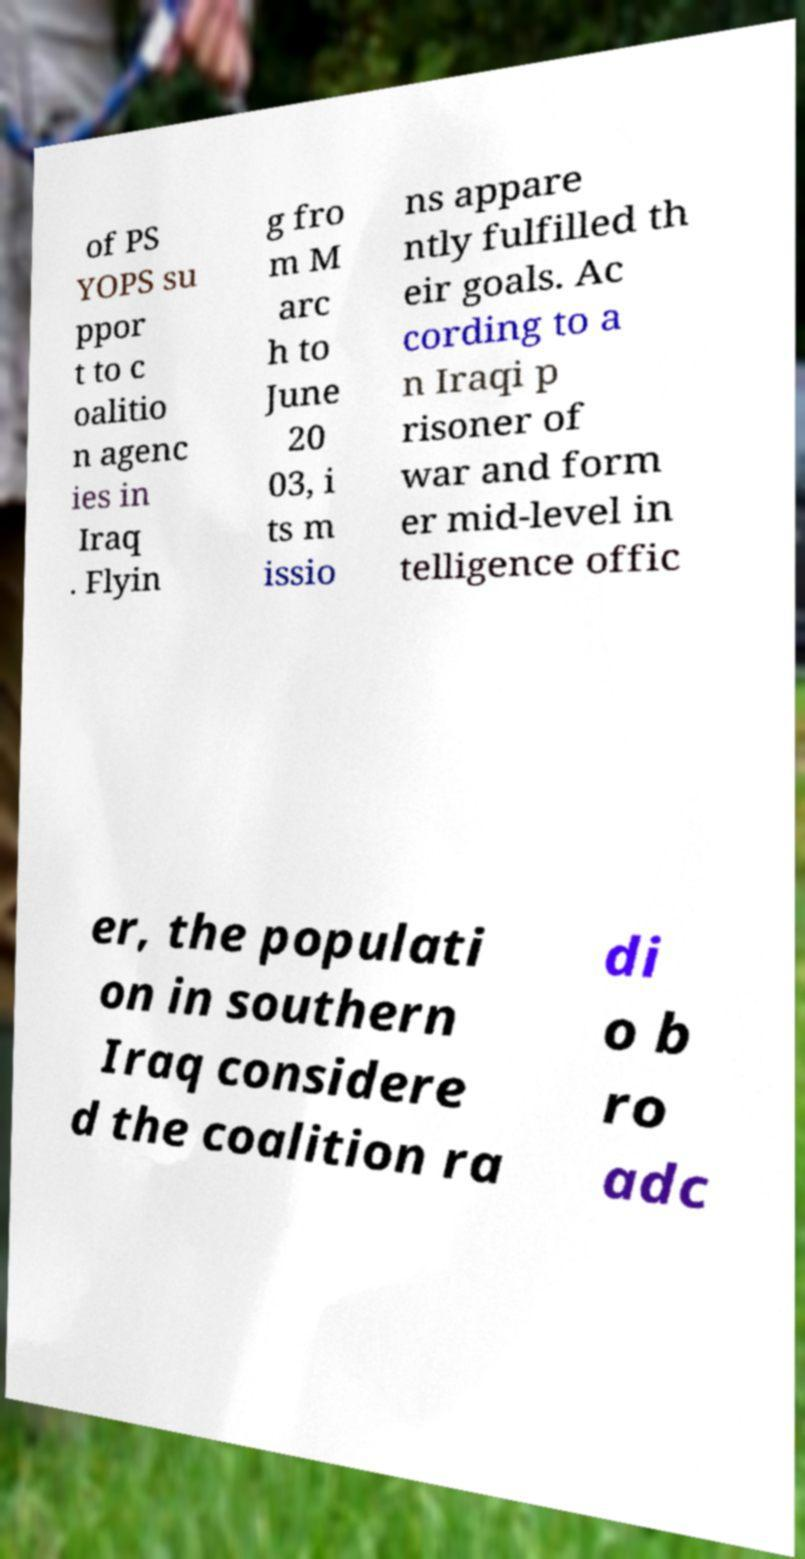For documentation purposes, I need the text within this image transcribed. Could you provide that? of PS YOPS su ppor t to c oalitio n agenc ies in Iraq . Flyin g fro m M arc h to June 20 03, i ts m issio ns appare ntly fulfilled th eir goals. Ac cording to a n Iraqi p risoner of war and form er mid-level in telligence offic er, the populati on in southern Iraq considere d the coalition ra di o b ro adc 